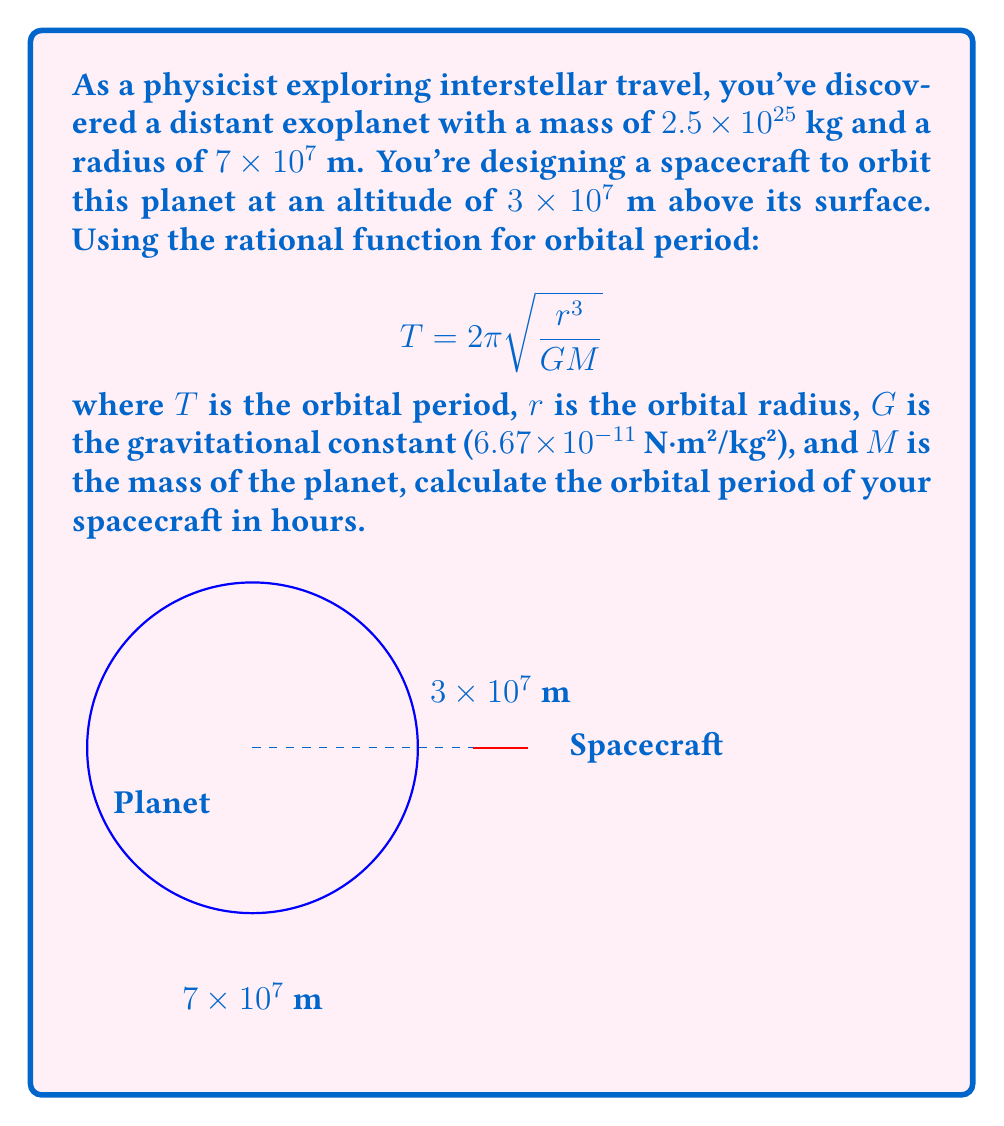Show me your answer to this math problem. Let's approach this step-by-step:

1) First, we need to calculate the orbital radius $r$. This is the sum of the planet's radius and the spacecraft's altitude:
   $r = 7 \times 10^7 \text{ m} + 3 \times 10^7 \text{ m} = 1 \times 10^8 \text{ m}$

2) Now we have all the values to plug into our equation:
   $T = 2\pi \sqrt{\frac{r^3}{GM}}$

   Where:
   $r = 1 \times 10^8 \text{ m}$
   $G = 6.67 \times 10^{-11} \text{ N⋅m²/kg²}$
   $M = 2.5 \times 10^{25} \text{ kg}$

3) Let's substitute these values:
   $T = 2\pi \sqrt{\frac{(1 \times 10^8)^3}{(6.67 \times 10^{-11})(2.5 \times 10^{25})}}$

4) Simplify inside the square root:
   $T = 2\pi \sqrt{\frac{1 \times 10^{24}}{1.6675 \times 10^{15}}}$

5) Divide inside the square root:
   $T = 2\pi \sqrt{5.997 \times 10^8}$

6) Take the square root:
   $T = 2\pi (2.449 \times 10^4)$

7) Multiply:
   $T = 1.539 \times 10^5 \text{ seconds}$

8) Convert to hours:
   $T = \frac{1.539 \times 10^5}{3600} = 42.75 \text{ hours}$
Answer: 42.75 hours 